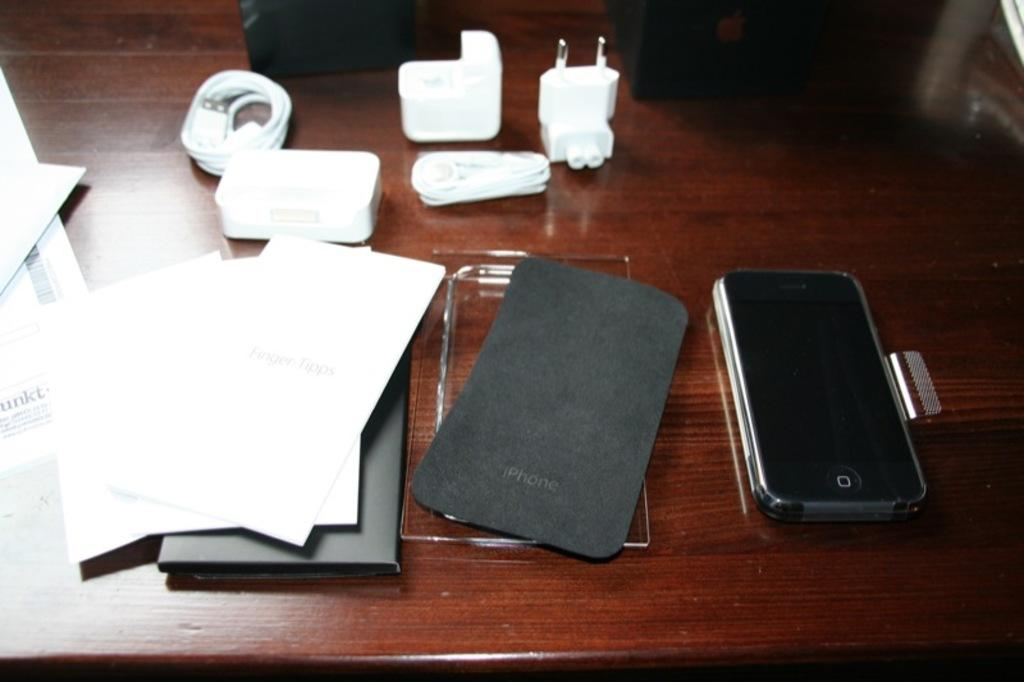What piece of furniture is present in the image? There is a table in the image. What is on top of the table? There is a mobile, a pouch, papers, a cable, and an adapter on the table. What might be used to charge electronic devices in the image? The adapter and cable on the table might be used to charge electronic devices. What type of angle can be seen in the image? There is no angle visible in the image; it is a still image of a table with various objects on it. 